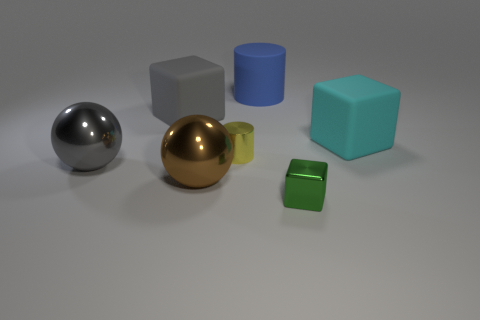Add 1 brown metal things. How many objects exist? 8 Subtract all spheres. How many objects are left? 5 Add 5 big cyan rubber blocks. How many big cyan rubber blocks are left? 6 Add 4 tiny green metallic spheres. How many tiny green metallic spheres exist? 4 Subtract 0 green cylinders. How many objects are left? 7 Subtract all large gray balls. Subtract all tiny purple metallic blocks. How many objects are left? 6 